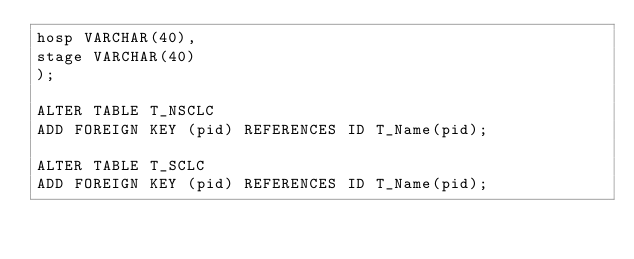<code> <loc_0><loc_0><loc_500><loc_500><_SQL_>hosp VARCHAR(40),
stage VARCHAR(40)
);

ALTER TABLE T_NSCLC
ADD FOREIGN KEY (pid) REFERENCES ID T_Name(pid);

ALTER TABLE T_SCLC
ADD FOREIGN KEY (pid) REFERENCES ID T_Name(pid);

</code> 